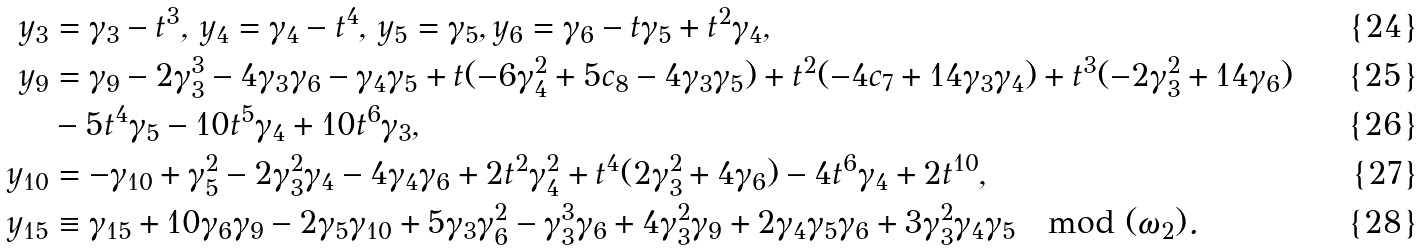<formula> <loc_0><loc_0><loc_500><loc_500>y _ { 3 } & = \gamma _ { 3 } - t ^ { 3 } , \, y _ { 4 } = \gamma _ { 4 } - t ^ { 4 } , \, y _ { 5 } = \gamma _ { 5 } , y _ { 6 } = \gamma _ { 6 } - t \gamma _ { 5 } + t ^ { 2 } \gamma _ { 4 } , \\ y _ { 9 } & = \gamma _ { 9 } - 2 \gamma _ { 3 } ^ { 3 } - 4 \gamma _ { 3 } \gamma _ { 6 } - \gamma _ { 4 } \gamma _ { 5 } + t ( - 6 \gamma _ { 4 } ^ { 2 } + 5 c _ { 8 } - 4 \gamma _ { 3 } \gamma _ { 5 } ) + t ^ { 2 } ( - 4 c _ { 7 } + 1 4 \gamma _ { 3 } \gamma _ { 4 } ) + t ^ { 3 } ( - 2 \gamma _ { 3 } ^ { 2 } + 1 4 \gamma _ { 6 } ) \\ & - 5 t ^ { 4 } \gamma _ { 5 } - 1 0 t ^ { 5 } \gamma _ { 4 } + 1 0 t ^ { 6 } \gamma _ { 3 } , \\ y _ { 1 0 } & = - \gamma _ { 1 0 } + \gamma _ { 5 } ^ { 2 } - 2 \gamma _ { 3 } ^ { 2 } \gamma _ { 4 } - 4 \gamma _ { 4 } \gamma _ { 6 } + 2 t ^ { 2 } \gamma _ { 4 } ^ { 2 } + t ^ { 4 } ( 2 \gamma _ { 3 } ^ { 2 } + 4 \gamma _ { 6 } ) - 4 t ^ { 6 } \gamma _ { 4 } + 2 t ^ { 1 0 } , \\ y _ { 1 5 } & \equiv \gamma _ { 1 5 } + 1 0 \gamma _ { 6 } \gamma _ { 9 } - 2 \gamma _ { 5 } \gamma _ { 1 0 } + 5 \gamma _ { 3 } \gamma _ { 6 } ^ { 2 } - \gamma _ { 3 } ^ { 3 } \gamma _ { 6 } + 4 \gamma _ { 3 } ^ { 2 } \gamma _ { 9 } + 2 \gamma _ { 4 } \gamma _ { 5 } \gamma _ { 6 } + 3 \gamma _ { 3 } ^ { 2 } \gamma _ { 4 } \gamma _ { 5 } \mod ( \omega _ { 2 } ) .</formula> 